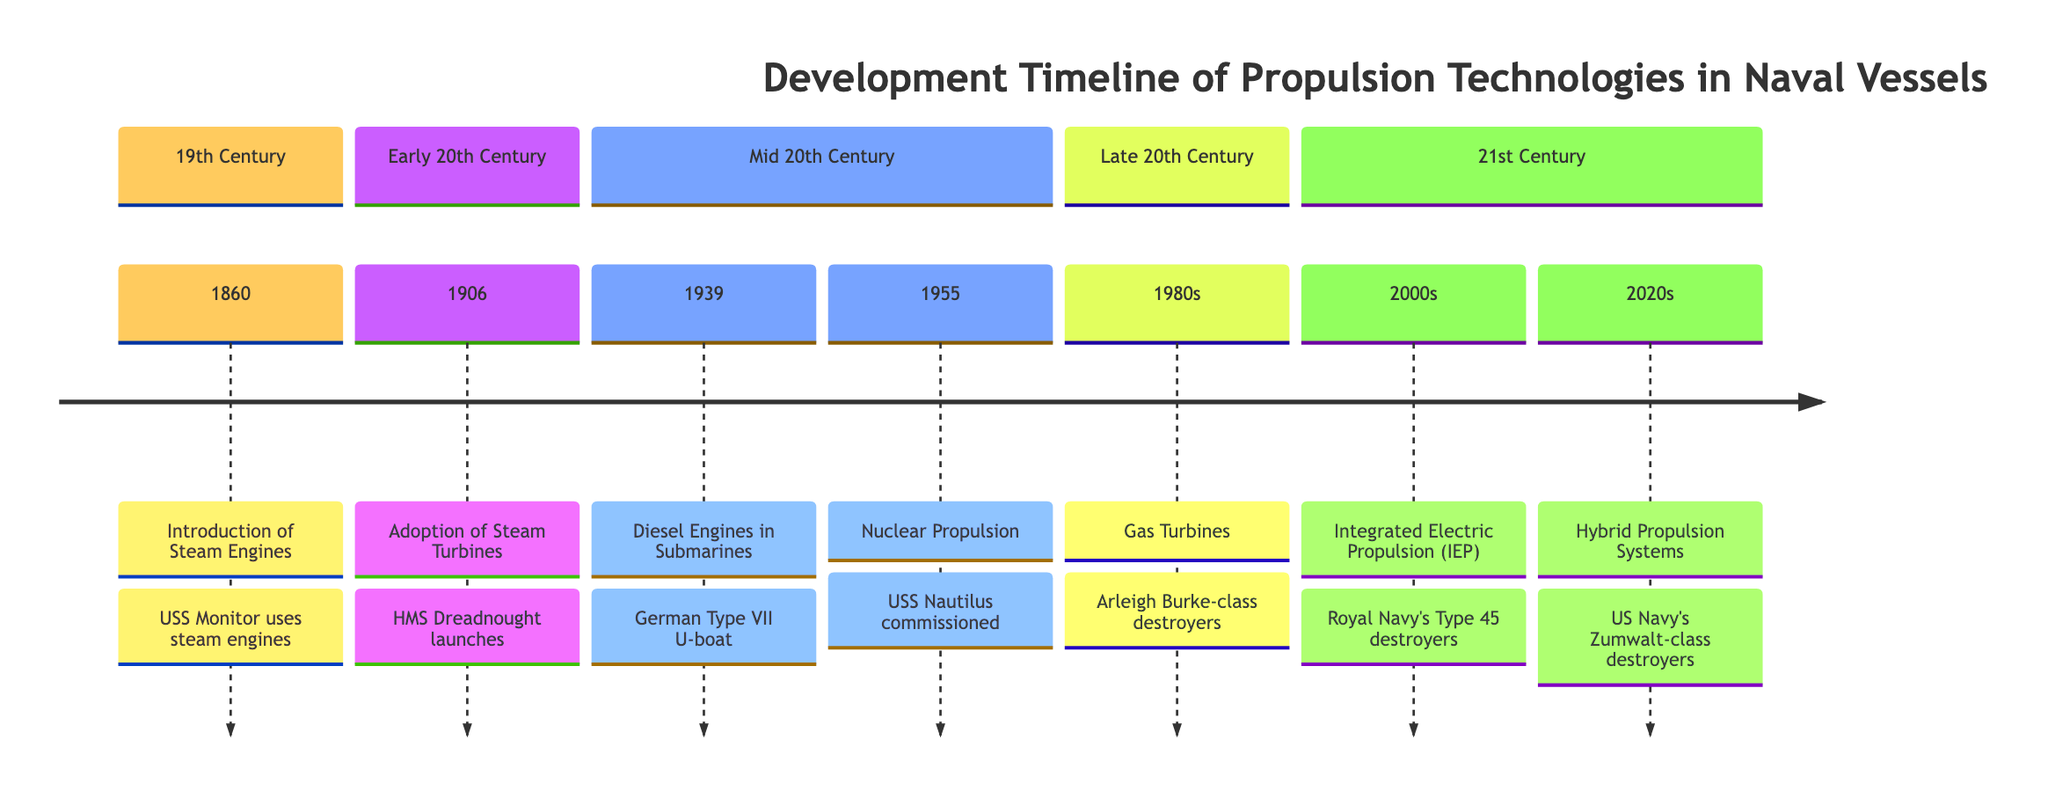What is the first propulsion technology introduced in naval vessels? The timeline starts with the year 1860, where the introduction of steam engines is noted. It specifically mentions the USS Monitor using steam engines for propulsion.
Answer: Steam Engines Which battleship is noted for the adoption of steam turbines? In the timeline for the year 1906, HMS Dreadnought is identified as the first battleship equipped with steam turbines, which is a significant advancement.
Answer: HMS Dreadnought What propulsion technology was used by the German Type VII U-boat? The timeline entry for 1939 states that the German Type VII U-boat uses diesel engines for surface travel. This indicates the propulsion technology used during that period.
Answer: Diesel Engines How many propulsion technologies are listed in the timeline? By counting the entries from the timeline, we see there are a total of seven entries describing different propulsion technologies introduced over time.
Answer: Seven What is the significance of the USS Nautilus commissioned in 1955? The timeline specifies that the USS Nautilus, the first operational nuclear-powered submarine, showcases the advantages of nuclear propulsion, marking a major development in naval propulsion technology.
Answer: Nuclear Propulsion In which decade did gas turbines start being introduced in naval vessels? The timeline indicates that gas turbines were introduced in the 1980s, specifically referencing the Arleigh Burke-class destroyers as an example from that period.
Answer: 1980s What does "Integrated Electric Propulsion (IEP)" combine? The timeline describes that IEP systems, adopted in the Royal Navy’s Type 45 destroyers, combine gas turbines and electric propulsion for improved efficiency.
Answer: Gas turbines and electric propulsion Which naval vessels adopted hybrid-electric propulsion systems in the 2020s? According to the timeline, the US Navy's Zumwalt-class destroyers are noted for their use of hybrid-electric propulsion systems, indicating their technological direction in this time period.
Answer: Zumwalt-class destroyers What year marks the introduction of hybrid propulsion systems? The timeline provides the information that hybrid propulsion systems began to be utilized in naval vessels during the 2020s, showcasing modern advancements in propulsion technology.
Answer: 2020s 